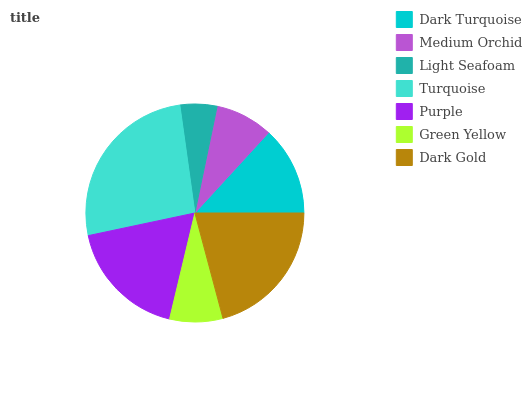Is Light Seafoam the minimum?
Answer yes or no. Yes. Is Turquoise the maximum?
Answer yes or no. Yes. Is Medium Orchid the minimum?
Answer yes or no. No. Is Medium Orchid the maximum?
Answer yes or no. No. Is Dark Turquoise greater than Medium Orchid?
Answer yes or no. Yes. Is Medium Orchid less than Dark Turquoise?
Answer yes or no. Yes. Is Medium Orchid greater than Dark Turquoise?
Answer yes or no. No. Is Dark Turquoise less than Medium Orchid?
Answer yes or no. No. Is Dark Turquoise the high median?
Answer yes or no. Yes. Is Dark Turquoise the low median?
Answer yes or no. Yes. Is Dark Gold the high median?
Answer yes or no. No. Is Light Seafoam the low median?
Answer yes or no. No. 